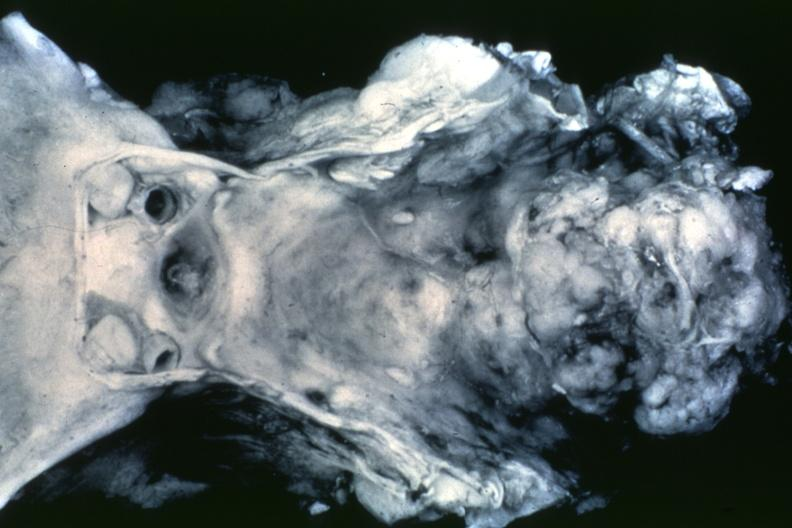s bone, clivus present?
Answer the question using a single word or phrase. Yes 